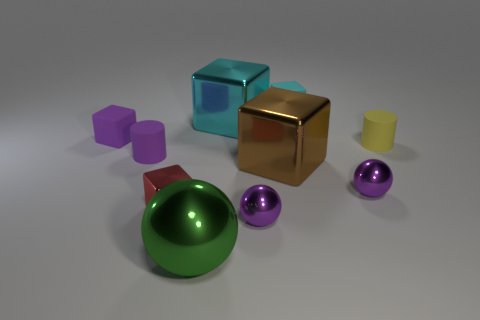Subtract all brown blocks. How many blocks are left? 4 Subtract all cyan rubber blocks. How many blocks are left? 4 Subtract all gray cubes. Subtract all green balls. How many cubes are left? 5 Subtract all spheres. How many objects are left? 7 Add 6 small purple spheres. How many small purple spheres are left? 8 Add 4 red objects. How many red objects exist? 5 Subtract 1 purple blocks. How many objects are left? 9 Subtract all matte things. Subtract all tiny purple metallic spheres. How many objects are left? 4 